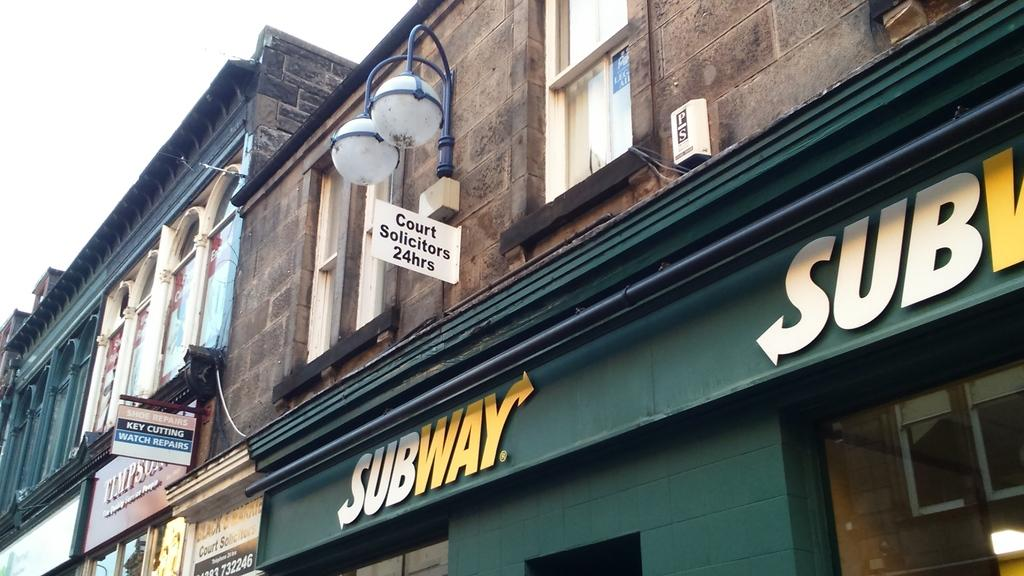What type of structures can be seen in the image? There are buildings in the image. What else is present on the buildings in the image? There are boards with text written on them. Are there any illumination sources visible in the image? Yes, there are lights visible in the image. What can be seen in the background of the image? The sky is visible in the image. What type of vessel is being used for hobbies in the image? There is no vessel or hobby-related activity present in the image. 